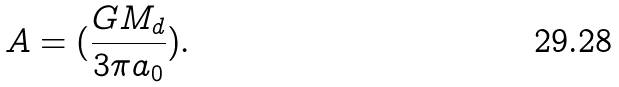<formula> <loc_0><loc_0><loc_500><loc_500>A = ( \frac { G M _ { d } } { 3 \pi a _ { 0 } } ) .</formula> 